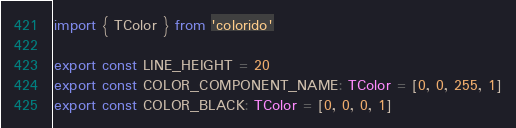Convert code to text. <code><loc_0><loc_0><loc_500><loc_500><_TypeScript_>import { TColor } from 'colorido'

export const LINE_HEIGHT = 20
export const COLOR_COMPONENT_NAME: TColor = [0, 0, 255, 1]
export const COLOR_BLACK: TColor = [0, 0, 0, 1]
</code> 